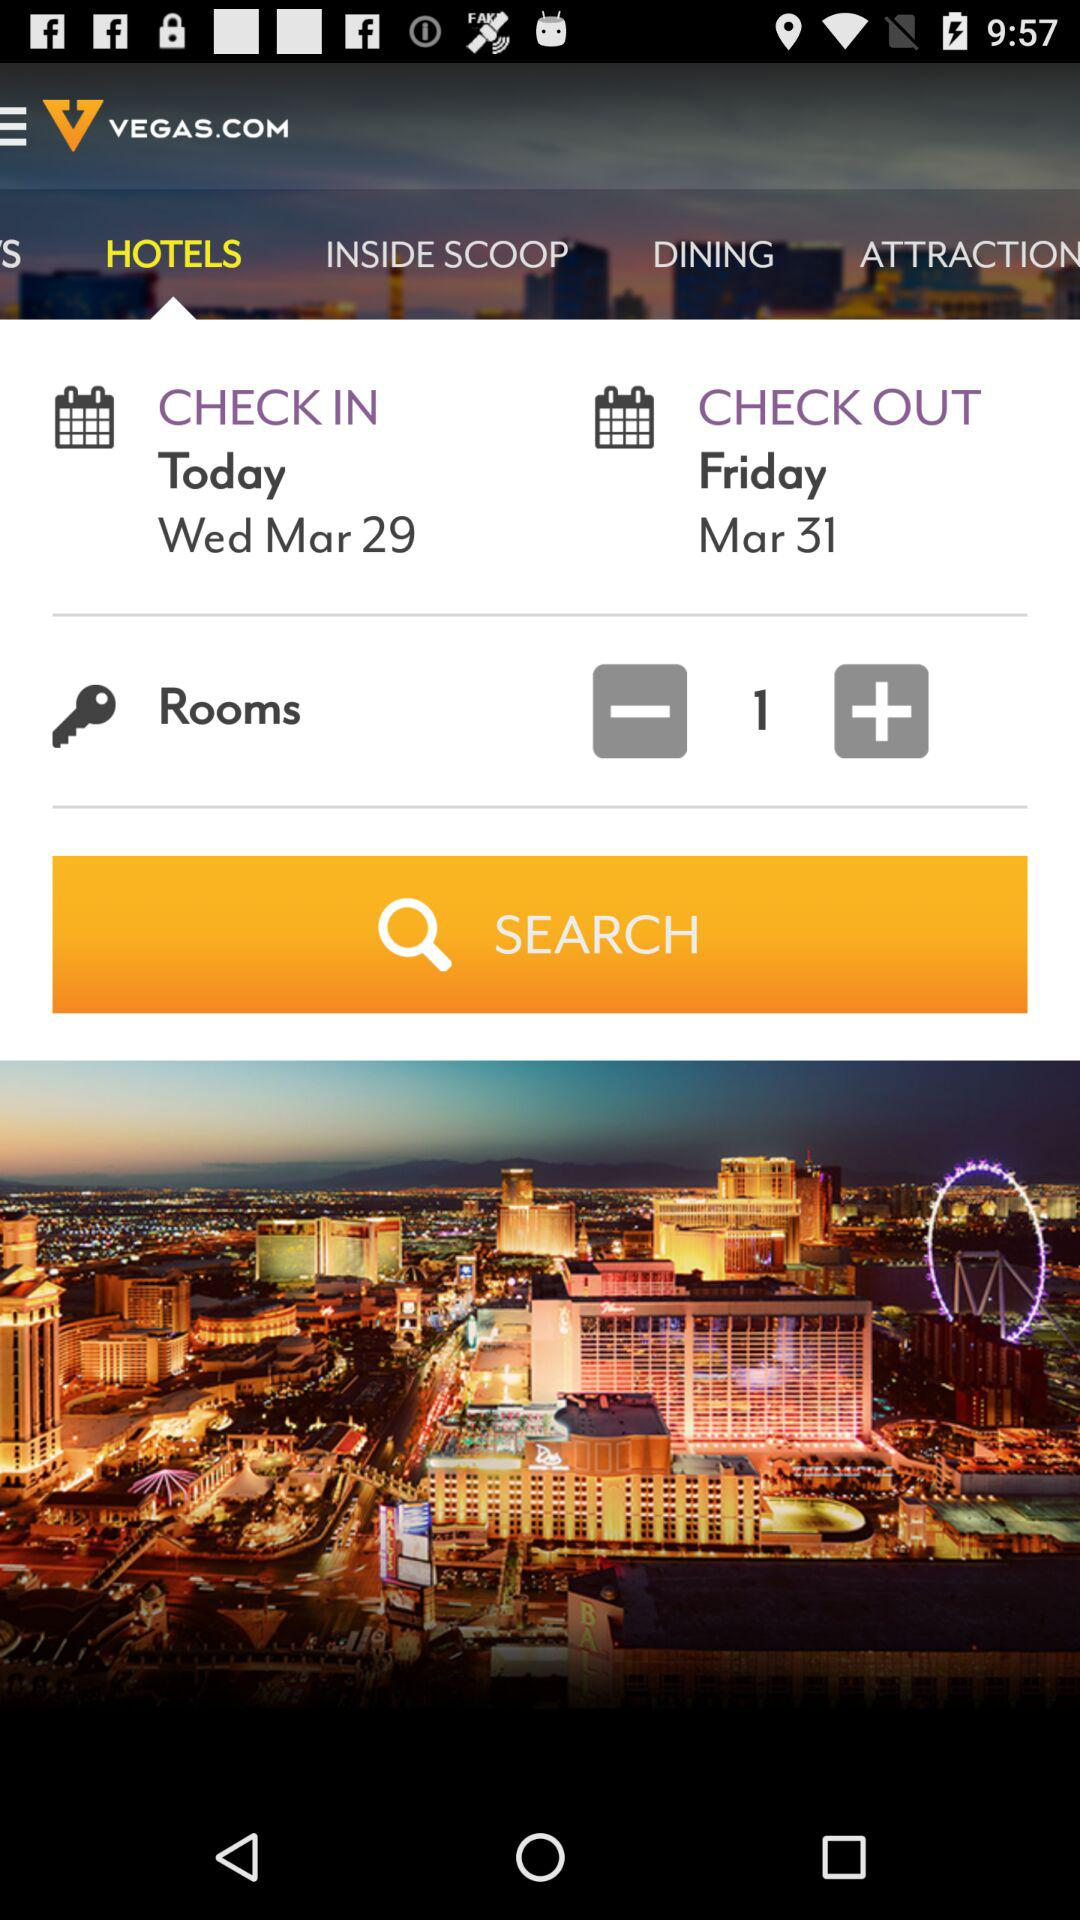What is the check-out date? The check-out date is Friday, March 31. 